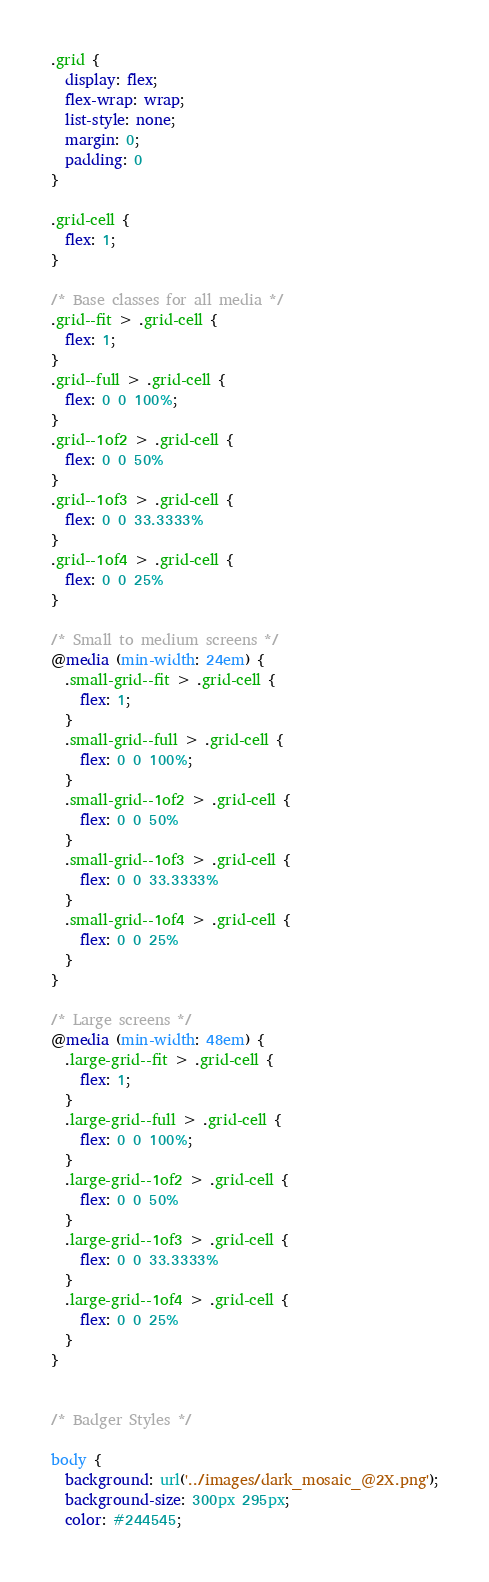Convert code to text. <code><loc_0><loc_0><loc_500><loc_500><_CSS_>.grid {
  display: flex;
  flex-wrap: wrap;
  list-style: none;
  margin: 0;
  padding: 0
}

.grid-cell {
  flex: 1;
}

/* Base classes for all media */
.grid--fit > .grid-cell {
  flex: 1;
}
.grid--full > .grid-cell {
  flex: 0 0 100%;
}
.grid--1of2 > .grid-cell {
  flex: 0 0 50%
}
.grid--1of3 > .grid-cell {
  flex: 0 0 33.3333%
}
.grid--1of4 > .grid-cell {
  flex: 0 0 25%
}

/* Small to medium screens */
@media (min-width: 24em) {
  .small-grid--fit > .grid-cell {
    flex: 1;
  }
  .small-grid--full > .grid-cell {
    flex: 0 0 100%;
  }
  .small-grid--1of2 > .grid-cell {
    flex: 0 0 50%
  }
  .small-grid--1of3 > .grid-cell {
    flex: 0 0 33.3333%
  }
  .small-grid--1of4 > .grid-cell {
    flex: 0 0 25%
  }
}

/* Large screens */
@media (min-width: 48em) {
  .large-grid--fit > .grid-cell {
    flex: 1;
  }
  .large-grid--full > .grid-cell {
    flex: 0 0 100%;
  }
  .large-grid--1of2 > .grid-cell {
    flex: 0 0 50%
  }
  .large-grid--1of3 > .grid-cell {
    flex: 0 0 33.3333%
  }
  .large-grid--1of4 > .grid-cell {
    flex: 0 0 25%
  }
}


/* Badger Styles */

body {
  background: url('../images/dark_mosaic_@2X.png');
  background-size: 300px 295px;
  color: #244545;</code> 